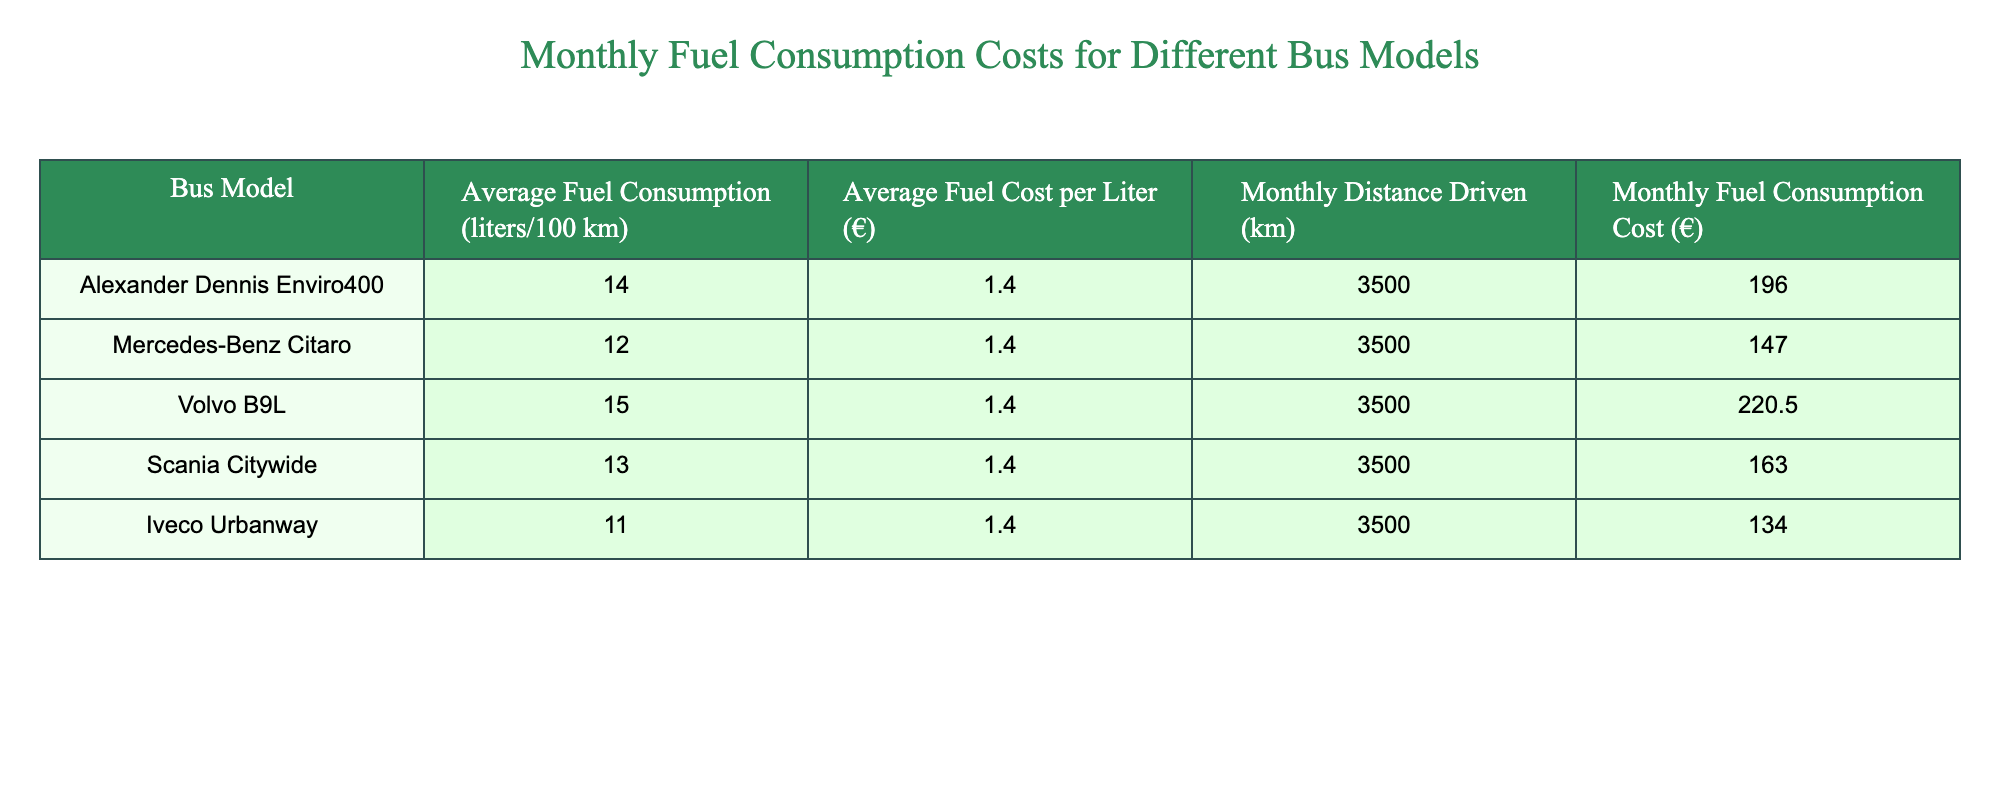What is the average fuel cost for the Alexander Dennis Enviro400 model? The average fuel cost for the Alexander Dennis Enviro400 model can be found in the fourth column of the table, which shows €196.00 as the Monthly Fuel Consumption Cost.
Answer: 196.00 Which bus model has the highest monthly fuel consumption cost? To determine the bus model with the highest monthly fuel consumption cost, we can look at the last column and compare the values: €196.00 for Alexander Dennis Enviro400, €147.00 for Mercedes-Benz Citaro, €220.50 for Volvo B9L, €163.00 for Scania Citywide, and €134.00 for Iveco Urbanway. The highest value is €220.50, corresponding to the Volvo B9L.
Answer: Volvo B9L What is the total monthly fuel consumption cost for all bus models? To find the total monthly fuel consumption cost, we sum the costs from the last column: €196.00 + €147.00 + €220.50 + €163.00 + €134.00 = €960.50.
Answer: 960.50 Is the average fuel consumption of the Mercedes-Benz Citaro lower than 13 liters per 100 km? The average fuel consumption for the Mercedes-Benz Citaro is shown in the second column as 12 liters per 100 km, which is indeed lower than 13 liters. Therefore, the statement is true.
Answer: Yes If the average fuel cost per liter increases to €1.50, what will be the new monthly fuel consumption cost for the Volvo B9L? Currently, the Volvo B9L has an average fuel consumption of 15 liters per 100 km and drives 3500 km monthly. The current cost is calculated as: (15/100) * 3500 * 1.40 = €220.50. With the new fuel cost of €1.50, the calculation would be (15/100) * 3500 * 1.50 = €262.50.
Answer: 262.50 